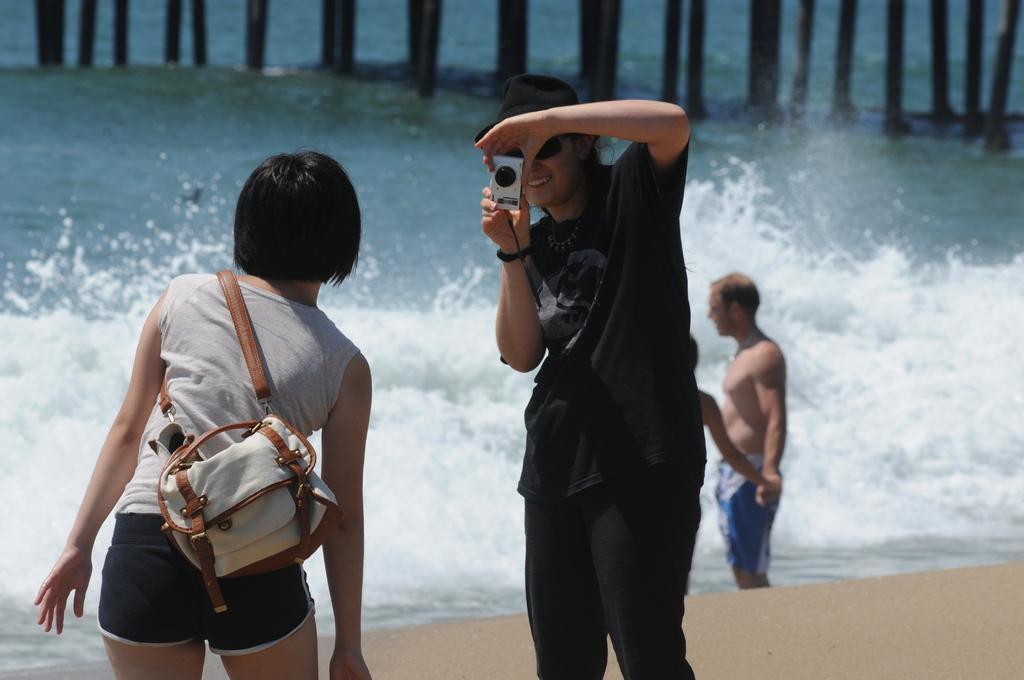Please provide a concise description of this image. In this picture we can see a woman wearing a black hat, holding a camera in her hand and taking a snap of this women. Here we can see persons standing in front of a sea. 